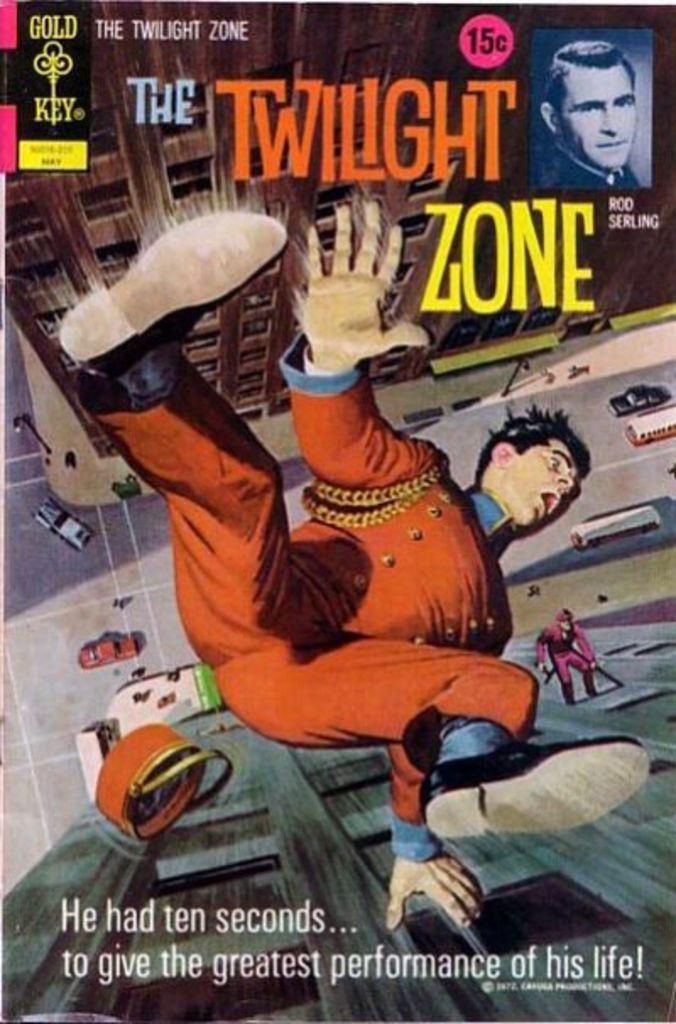In one or two sentences, can you explain what this image depicts? In this picture we can see a poster, in the poster we can find few cartoon images and buildings, and also we can see some text. 